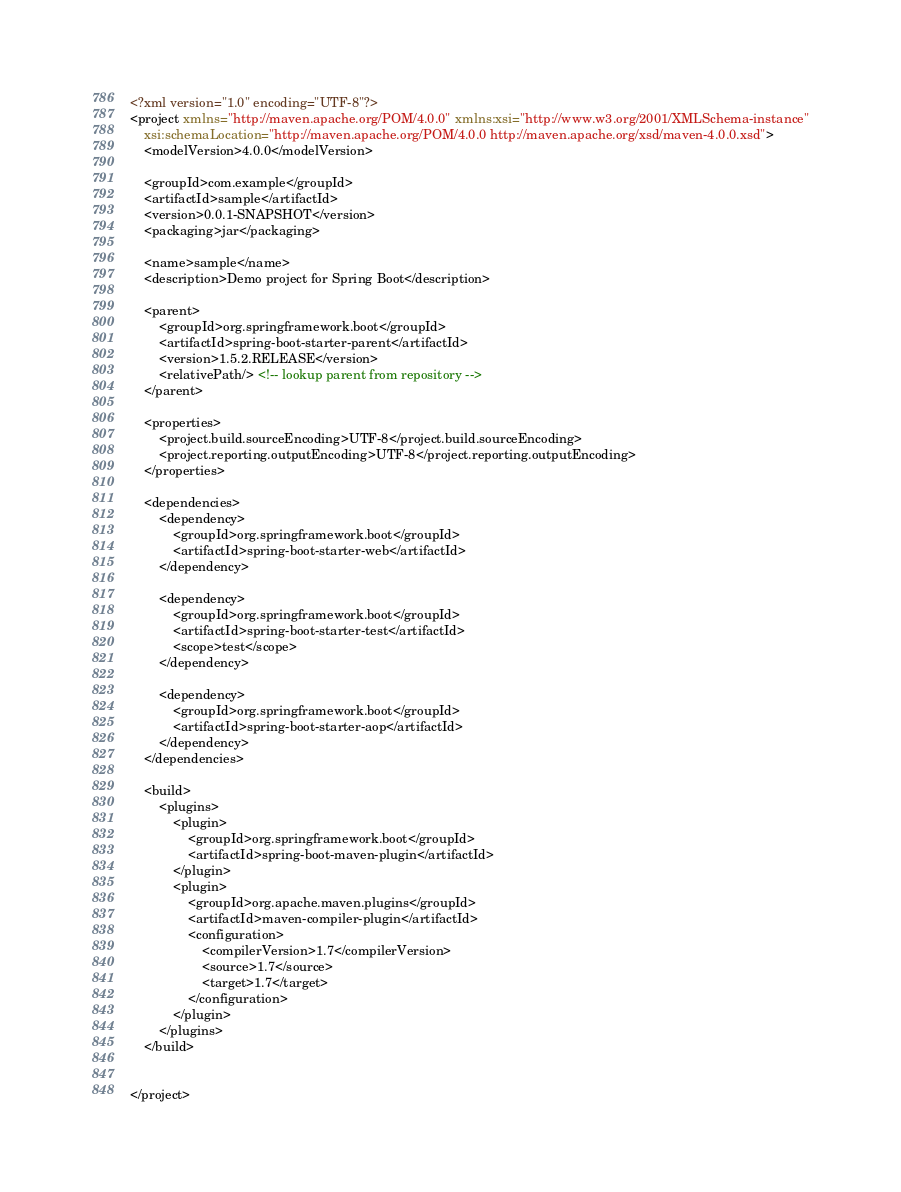Convert code to text. <code><loc_0><loc_0><loc_500><loc_500><_XML_><?xml version="1.0" encoding="UTF-8"?>
<project xmlns="http://maven.apache.org/POM/4.0.0" xmlns:xsi="http://www.w3.org/2001/XMLSchema-instance"
	xsi:schemaLocation="http://maven.apache.org/POM/4.0.0 http://maven.apache.org/xsd/maven-4.0.0.xsd">
	<modelVersion>4.0.0</modelVersion>

	<groupId>com.example</groupId>
	<artifactId>sample</artifactId>
	<version>0.0.1-SNAPSHOT</version>
	<packaging>jar</packaging>

	<name>sample</name>
	<description>Demo project for Spring Boot</description>

	<parent>
		<groupId>org.springframework.boot</groupId>
		<artifactId>spring-boot-starter-parent</artifactId>
		<version>1.5.2.RELEASE</version>
		<relativePath/> <!-- lookup parent from repository -->
	</parent>

	<properties>
		<project.build.sourceEncoding>UTF-8</project.build.sourceEncoding>
		<project.reporting.outputEncoding>UTF-8</project.reporting.outputEncoding>
	</properties>

	<dependencies>
		<dependency>
			<groupId>org.springframework.boot</groupId>
			<artifactId>spring-boot-starter-web</artifactId>
		</dependency>

		<dependency>
			<groupId>org.springframework.boot</groupId>
			<artifactId>spring-boot-starter-test</artifactId>
			<scope>test</scope>
		</dependency>

		<dependency>
			<groupId>org.springframework.boot</groupId>
			<artifactId>spring-boot-starter-aop</artifactId>
		</dependency>
	</dependencies>

	<build>
		<plugins>
			<plugin>
				<groupId>org.springframework.boot</groupId>
				<artifactId>spring-boot-maven-plugin</artifactId>
			</plugin>
			<plugin>
				<groupId>org.apache.maven.plugins</groupId>
				<artifactId>maven-compiler-plugin</artifactId>
				<configuration>
					<compilerVersion>1.7</compilerVersion>
					<source>1.7</source>
					<target>1.7</target>
				</configuration>
			</plugin>
		</plugins>
	</build>


</project>
</code> 